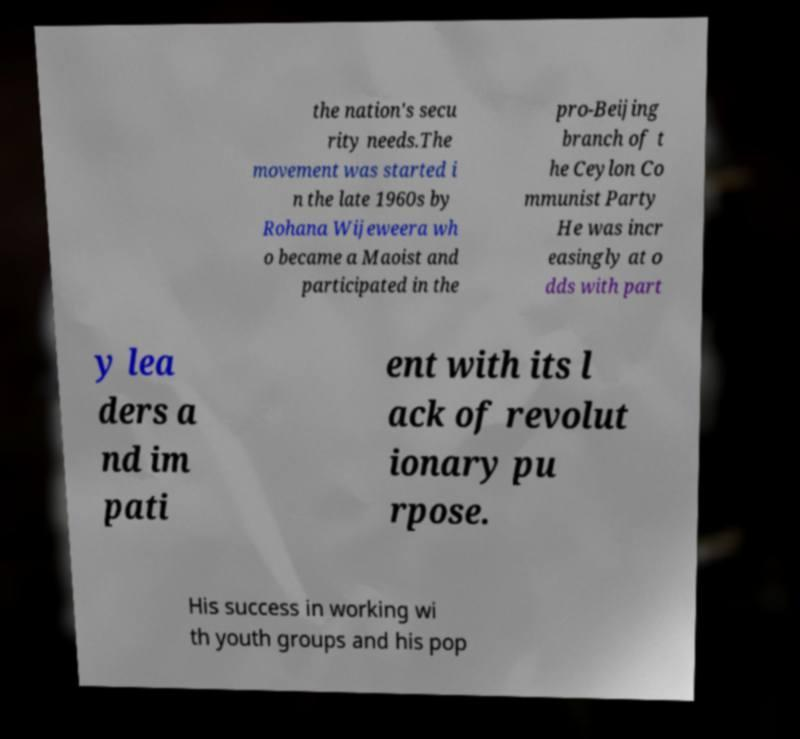Please identify and transcribe the text found in this image. the nation's secu rity needs.The movement was started i n the late 1960s by Rohana Wijeweera wh o became a Maoist and participated in the pro-Beijing branch of t he Ceylon Co mmunist Party He was incr easingly at o dds with part y lea ders a nd im pati ent with its l ack of revolut ionary pu rpose. His success in working wi th youth groups and his pop 